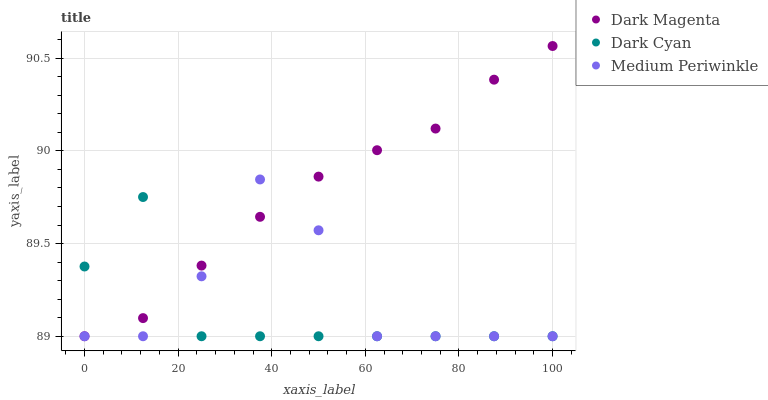Does Dark Cyan have the minimum area under the curve?
Answer yes or no. Yes. Does Dark Magenta have the maximum area under the curve?
Answer yes or no. Yes. Does Medium Periwinkle have the minimum area under the curve?
Answer yes or no. No. Does Medium Periwinkle have the maximum area under the curve?
Answer yes or no. No. Is Dark Magenta the smoothest?
Answer yes or no. Yes. Is Medium Periwinkle the roughest?
Answer yes or no. Yes. Is Medium Periwinkle the smoothest?
Answer yes or no. No. Is Dark Magenta the roughest?
Answer yes or no. No. Does Dark Cyan have the lowest value?
Answer yes or no. Yes. Does Dark Magenta have the highest value?
Answer yes or no. Yes. Does Medium Periwinkle have the highest value?
Answer yes or no. No. Does Dark Cyan intersect Dark Magenta?
Answer yes or no. Yes. Is Dark Cyan less than Dark Magenta?
Answer yes or no. No. Is Dark Cyan greater than Dark Magenta?
Answer yes or no. No. 